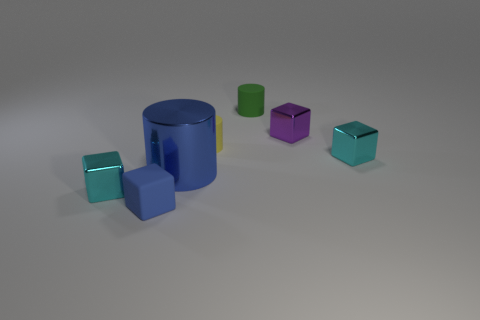How many objects are in total and can you describe their shapes? There are seven objects in the image. There is one large blue cylinder with a yellow stripe, four cubes in different colors (teal, green, purple, and teal with a different shade), and two smaller cylinders in green and purple. 